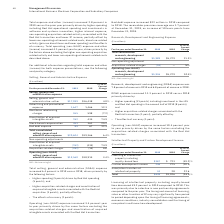According to International Business Machines's financial document, What caused the Total selling, general and administrative (SG&A) expense to increase? Higher spending (5 points) driven by Red Hat spending (5 points); and • Higher acquisition-related charges and amortization of acquired intangible assets associated with the Red Hat acquisition (3 points); partially offset by • The effects of currency (2 points).. The document states: "• Higher spending (5 points) driven by Red Hat spending (5 points); and • Higher acquisition-related charges and amortization of acquired intangible a..." Also, What caused the Operating (non-GAAP) expense to increase? driven by the same factors excluding the acquisition-related charges and amortization of acquired intangible assets associated with the Red Hat transaction.. The document states: "pense increased 3.4 percent year to year primarily driven by the same factors excluding the acquisition-related charges and amortization of acquired i..." Also, What were the Bad debt expenses in 2019? According to the financial document, 89 (in millions). The relevant text states: "Bad debt expense 89 67 32.5..." Also, can you calculate: What was the increase / (decrease) in the Selling, general and administrative—other from 2018 to 2019? Based on the calculation: 17,099 - 16,438, the result is 661 (in millions). This is based on the information: "elling, general and administrative—other $17,099 $16,438 4.0% Selling, general and administrative—other $17,099 $16,438 4.0%..." The key data points involved are: 16,438, 17,099. Also, can you calculate: What was the average of Advertising and promotional expense? To answer this question, I need to perform calculations using the financial data. The calculation is: (1,647 + 1,466) / 2, which equals 1556.5 (in millions). This is based on the information: "Advertising and promotional expense 1,647 1,466 12.3 Advertising and promotional expense 1,647 1,466 12.3..." The key data points involved are: 1,466, 1,647. Also, can you calculate: What is the increase / (decrease) in the Stock-based compensation from 2018 to 2019? Based on the calculation: 453 - 361, the result is 92 (in millions). This is based on the information: "Stock-based compensation 453 361 25.2 Stock-based compensation 453 361 25.2..." The key data points involved are: 361, 453. 